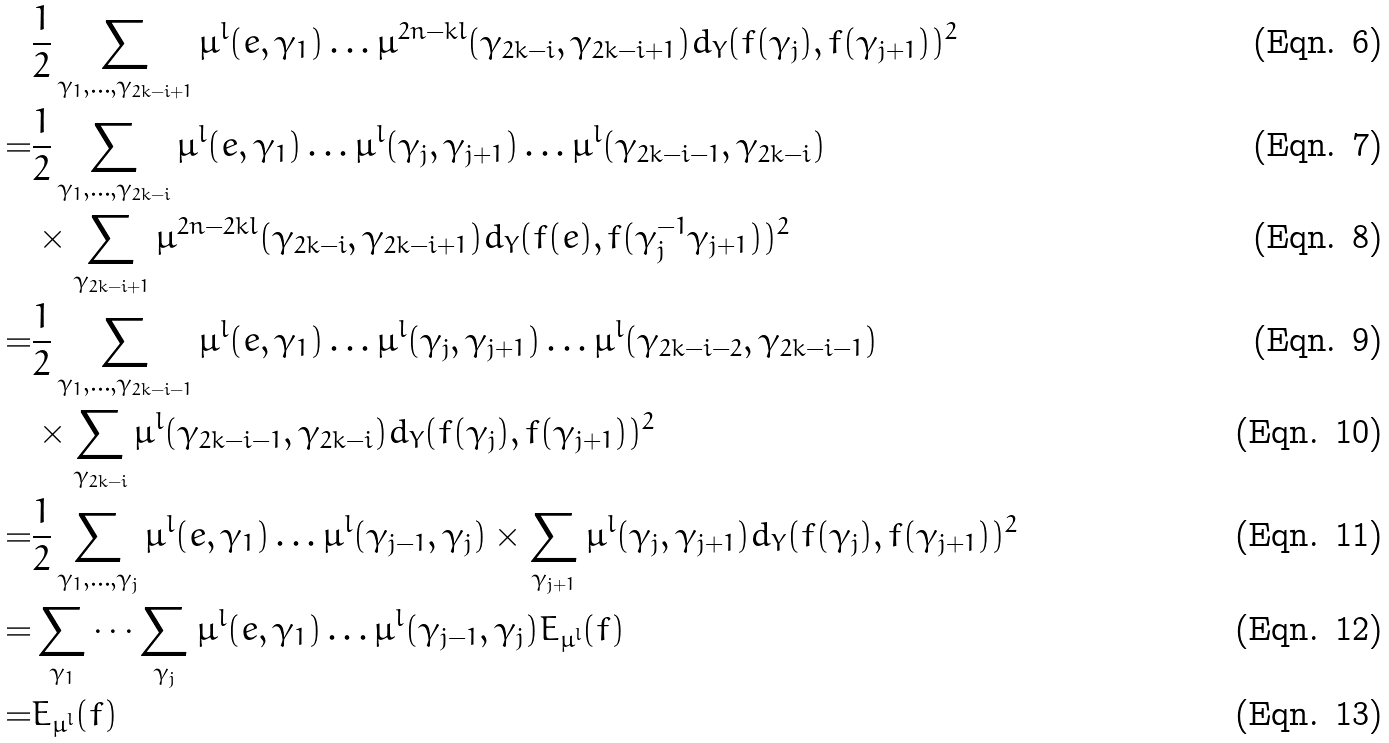<formula> <loc_0><loc_0><loc_500><loc_500>& \frac { 1 } { 2 } \sum _ { \gamma _ { 1 } , \dots , \gamma _ { 2 k - i + 1 } } \mu ^ { l } ( e , \gamma _ { 1 } ) \dots \mu ^ { 2 n - k l } ( \gamma _ { 2 k - i } , \gamma _ { 2 k - i + 1 } ) d _ { Y } ( f ( \gamma _ { j } ) , f ( \gamma _ { j + 1 } ) ) ^ { 2 } \\ = & \frac { 1 } { 2 } \sum _ { \gamma _ { 1 } , \dots , \gamma _ { 2 k - i } } \mu ^ { l } ( e , \gamma _ { 1 } ) \dots \mu ^ { l } ( \gamma _ { j } , \gamma _ { j + 1 } ) \dots \mu ^ { l } ( \gamma _ { 2 k - i - 1 } , \gamma _ { 2 k - i } ) \\ & \times \sum _ { \gamma _ { 2 k - i + 1 } } \mu ^ { 2 n - 2 k l } ( \gamma _ { 2 k - i } , \gamma _ { 2 k - i + 1 } ) d _ { Y } ( f ( e ) , f ( \gamma _ { j } ^ { - 1 } \gamma _ { j + 1 } ) ) ^ { 2 } \\ = & \frac { 1 } { 2 } \sum _ { \gamma _ { 1 } , \dots , \gamma _ { 2 k - i - 1 } } \mu ^ { l } ( e , \gamma _ { 1 } ) \dots \mu ^ { l } ( \gamma _ { j } , \gamma _ { j + 1 } ) \dots \mu ^ { l } ( \gamma _ { 2 k - i - 2 } , \gamma _ { 2 k - i - 1 } ) \\ & \times \sum _ { \gamma _ { 2 k - i } } \mu ^ { l } ( \gamma _ { 2 k - i - 1 } , \gamma _ { 2 k - i } ) d _ { Y } ( f ( \gamma _ { j } ) , f ( \gamma _ { j + 1 } ) ) ^ { 2 } \\ = & \frac { 1 } { 2 } \sum _ { \gamma _ { 1 } , \dots , \gamma _ { j } } \mu ^ { l } ( e , \gamma _ { 1 } ) \dots \mu ^ { l } ( \gamma _ { j - 1 } , \gamma _ { j } ) \times \sum _ { \gamma _ { j + 1 } } \mu ^ { l } ( \gamma _ { j } , \gamma _ { j + 1 } ) d _ { Y } ( f ( \gamma _ { j } ) , f ( \gamma _ { j + 1 } ) ) ^ { 2 } \\ = & \sum _ { \gamma _ { 1 } } \dots \sum _ { \gamma _ { j } } \mu ^ { l } ( e , \gamma _ { 1 } ) \dots \mu ^ { l } ( \gamma _ { j - 1 } , \gamma _ { j } ) E _ { \mu ^ { l } } ( f ) \\ = & E _ { \mu ^ { l } } ( f )</formula> 